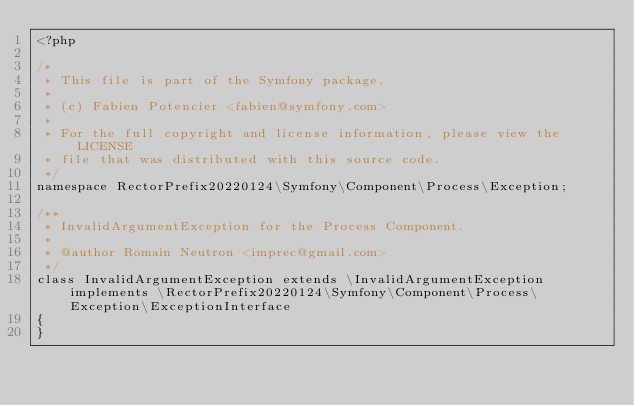Convert code to text. <code><loc_0><loc_0><loc_500><loc_500><_PHP_><?php

/*
 * This file is part of the Symfony package.
 *
 * (c) Fabien Potencier <fabien@symfony.com>
 *
 * For the full copyright and license information, please view the LICENSE
 * file that was distributed with this source code.
 */
namespace RectorPrefix20220124\Symfony\Component\Process\Exception;

/**
 * InvalidArgumentException for the Process Component.
 *
 * @author Romain Neutron <imprec@gmail.com>
 */
class InvalidArgumentException extends \InvalidArgumentException implements \RectorPrefix20220124\Symfony\Component\Process\Exception\ExceptionInterface
{
}
</code> 